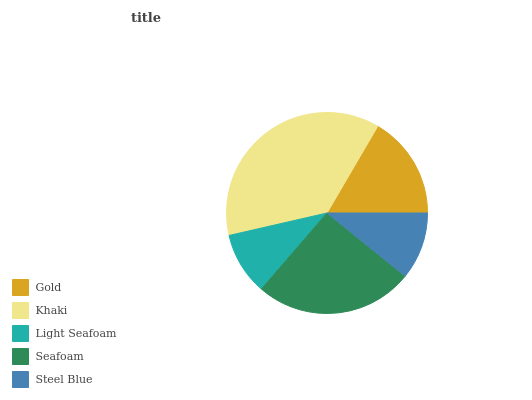Is Light Seafoam the minimum?
Answer yes or no. Yes. Is Khaki the maximum?
Answer yes or no. Yes. Is Khaki the minimum?
Answer yes or no. No. Is Light Seafoam the maximum?
Answer yes or no. No. Is Khaki greater than Light Seafoam?
Answer yes or no. Yes. Is Light Seafoam less than Khaki?
Answer yes or no. Yes. Is Light Seafoam greater than Khaki?
Answer yes or no. No. Is Khaki less than Light Seafoam?
Answer yes or no. No. Is Gold the high median?
Answer yes or no. Yes. Is Gold the low median?
Answer yes or no. Yes. Is Steel Blue the high median?
Answer yes or no. No. Is Seafoam the low median?
Answer yes or no. No. 